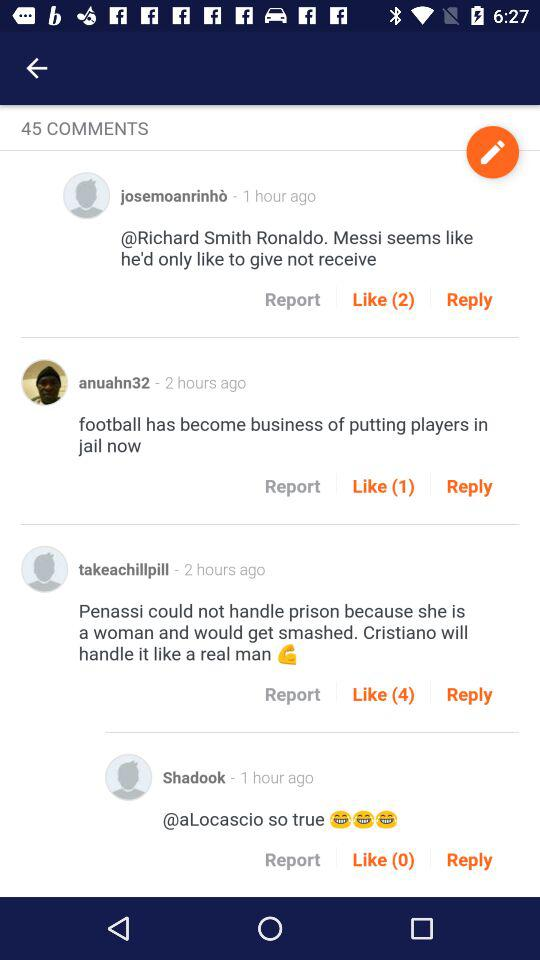How many people have liked the comment made by "josemoanrinhò"? There are 2 people who have liked the comment made by "josemoanrinhò". 